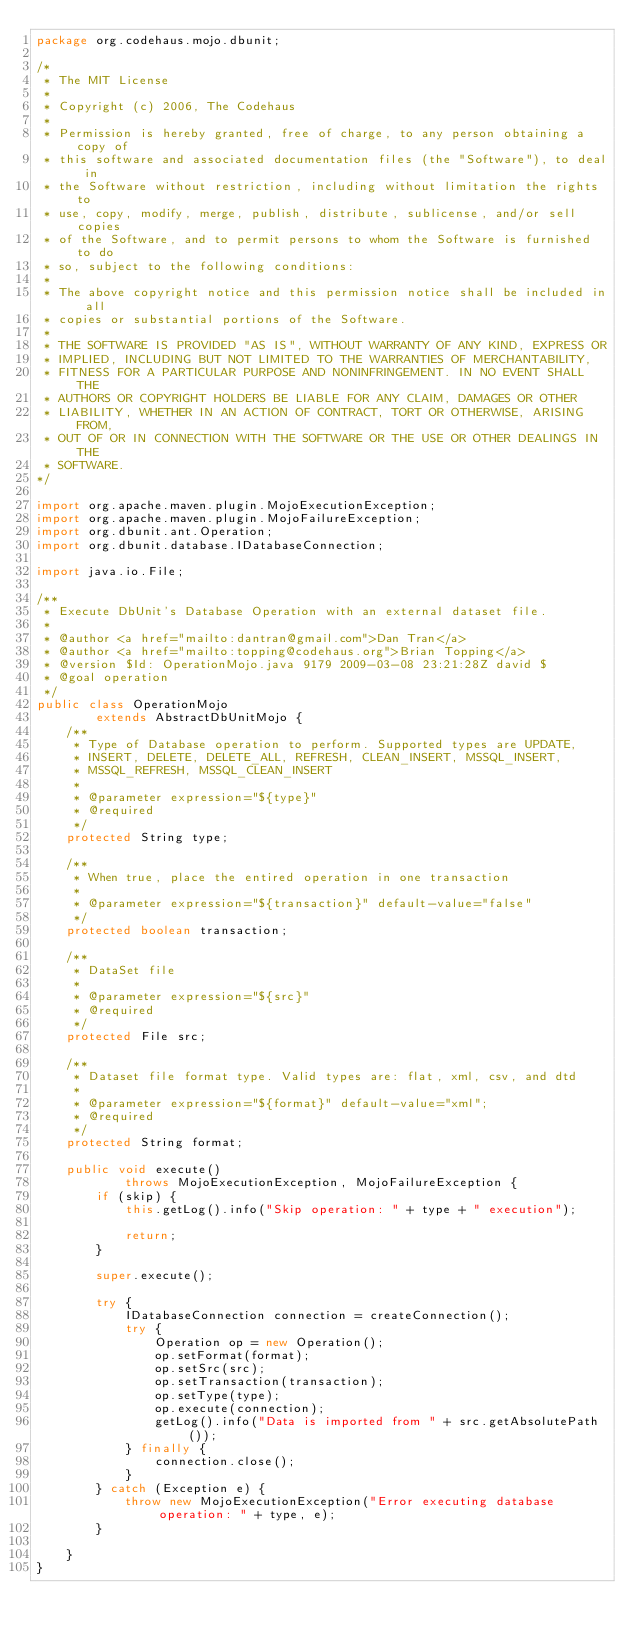<code> <loc_0><loc_0><loc_500><loc_500><_Java_>package org.codehaus.mojo.dbunit;

/*
 * The MIT License
 *
 * Copyright (c) 2006, The Codehaus
 *
 * Permission is hereby granted, free of charge, to any person obtaining a copy of
 * this software and associated documentation files (the "Software"), to deal in
 * the Software without restriction, including without limitation the rights to
 * use, copy, modify, merge, publish, distribute, sublicense, and/or sell copies
 * of the Software, and to permit persons to whom the Software is furnished to do
 * so, subject to the following conditions:
 * 
 * The above copyright notice and this permission notice shall be included in all
 * copies or substantial portions of the Software.
 * 
 * THE SOFTWARE IS PROVIDED "AS IS", WITHOUT WARRANTY OF ANY KIND, EXPRESS OR
 * IMPLIED, INCLUDING BUT NOT LIMITED TO THE WARRANTIES OF MERCHANTABILITY,
 * FITNESS FOR A PARTICULAR PURPOSE AND NONINFRINGEMENT. IN NO EVENT SHALL THE
 * AUTHORS OR COPYRIGHT HOLDERS BE LIABLE FOR ANY CLAIM, DAMAGES OR OTHER
 * LIABILITY, WHETHER IN AN ACTION OF CONTRACT, TORT OR OTHERWISE, ARISING FROM,
 * OUT OF OR IN CONNECTION WITH THE SOFTWARE OR THE USE OR OTHER DEALINGS IN THE
 * SOFTWARE.
*/

import org.apache.maven.plugin.MojoExecutionException;
import org.apache.maven.plugin.MojoFailureException;
import org.dbunit.ant.Operation;
import org.dbunit.database.IDatabaseConnection;

import java.io.File;

/**
 * Execute DbUnit's Database Operation with an external dataset file.
 *
 * @author <a href="mailto:dantran@gmail.com">Dan Tran</a>
 * @author <a href="mailto:topping@codehaus.org">Brian Topping</a>
 * @version $Id: OperationMojo.java 9179 2009-03-08 23:21:28Z david $
 * @goal operation
 */
public class OperationMojo
        extends AbstractDbUnitMojo {
    /**
     * Type of Database operation to perform. Supported types are UPDATE,
     * INSERT, DELETE, DELETE_ALL, REFRESH, CLEAN_INSERT, MSSQL_INSERT,
     * MSSQL_REFRESH, MSSQL_CLEAN_INSERT
     *
     * @parameter expression="${type}"
     * @required
     */
    protected String type;

    /**
     * When true, place the entired operation in one transaction
     *
     * @parameter expression="${transaction}" default-value="false"
     */
    protected boolean transaction;

    /**
     * DataSet file
     *
     * @parameter expression="${src}"
     * @required
     */
    protected File src;

    /**
     * Dataset file format type. Valid types are: flat, xml, csv, and dtd
     *
     * @parameter expression="${format}" default-value="xml";
     * @required
     */
    protected String format;

    public void execute()
            throws MojoExecutionException, MojoFailureException {
        if (skip) {
            this.getLog().info("Skip operation: " + type + " execution");

            return;
        }

        super.execute();

        try {
            IDatabaseConnection connection = createConnection();
            try {
                Operation op = new Operation();
                op.setFormat(format);
                op.setSrc(src);
                op.setTransaction(transaction);
                op.setType(type);
                op.execute(connection);
                getLog().info("Data is imported from " + src.getAbsolutePath());
            } finally {
                connection.close();
            }
        } catch (Exception e) {
            throw new MojoExecutionException("Error executing database operation: " + type, e);
        }

    }
}
</code> 